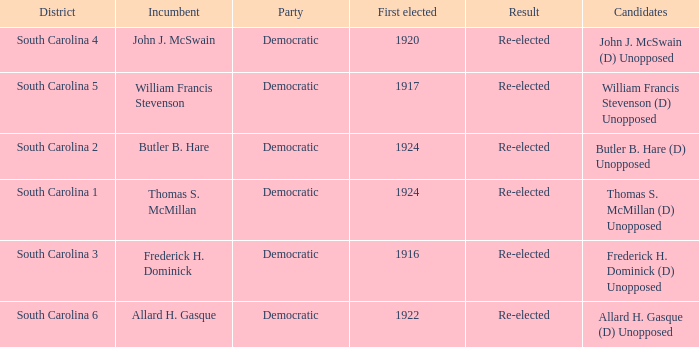What is the result for thomas s. mcmillan? Re-elected. 